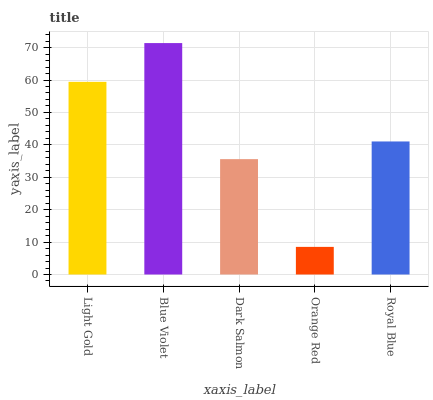Is Orange Red the minimum?
Answer yes or no. Yes. Is Blue Violet the maximum?
Answer yes or no. Yes. Is Dark Salmon the minimum?
Answer yes or no. No. Is Dark Salmon the maximum?
Answer yes or no. No. Is Blue Violet greater than Dark Salmon?
Answer yes or no. Yes. Is Dark Salmon less than Blue Violet?
Answer yes or no. Yes. Is Dark Salmon greater than Blue Violet?
Answer yes or no. No. Is Blue Violet less than Dark Salmon?
Answer yes or no. No. Is Royal Blue the high median?
Answer yes or no. Yes. Is Royal Blue the low median?
Answer yes or no. Yes. Is Orange Red the high median?
Answer yes or no. No. Is Dark Salmon the low median?
Answer yes or no. No. 